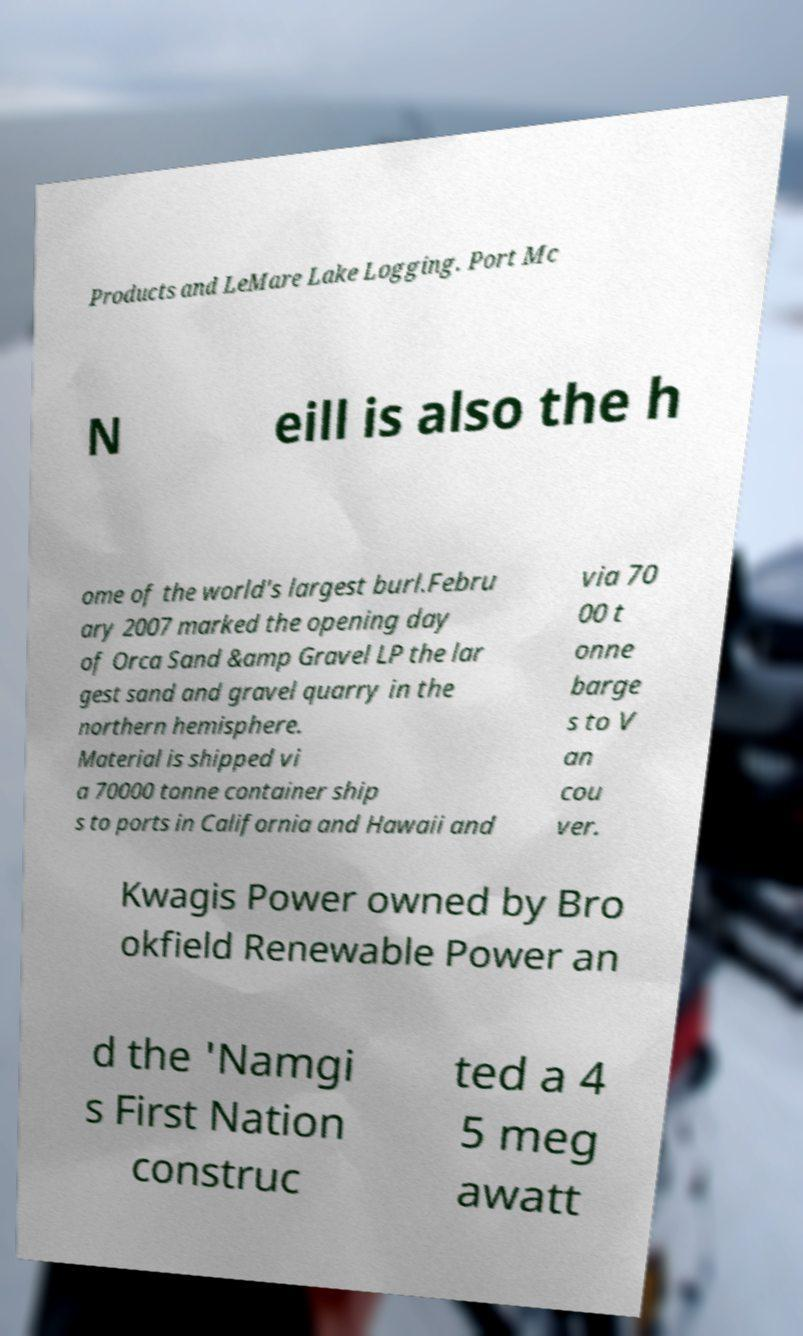I need the written content from this picture converted into text. Can you do that? Products and LeMare Lake Logging. Port Mc N eill is also the h ome of the world's largest burl.Febru ary 2007 marked the opening day of Orca Sand &amp Gravel LP the lar gest sand and gravel quarry in the northern hemisphere. Material is shipped vi a 70000 tonne container ship s to ports in California and Hawaii and via 70 00 t onne barge s to V an cou ver. Kwagis Power owned by Bro okfield Renewable Power an d the 'Namgi s First Nation construc ted a 4 5 meg awatt 